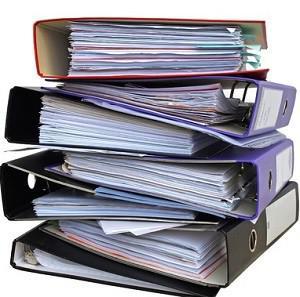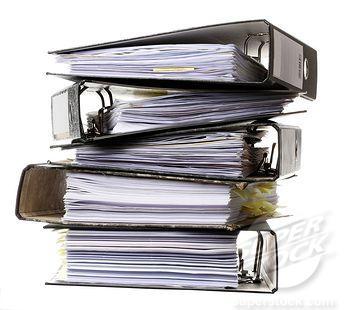The first image is the image on the left, the second image is the image on the right. Considering the images on both sides, is "The left image has at least four binders stacked vertically in it." valid? Answer yes or no. Yes. The first image is the image on the left, the second image is the image on the right. Considering the images on both sides, is "binders are stacked on their sides with paper inside" valid? Answer yes or no. Yes. 